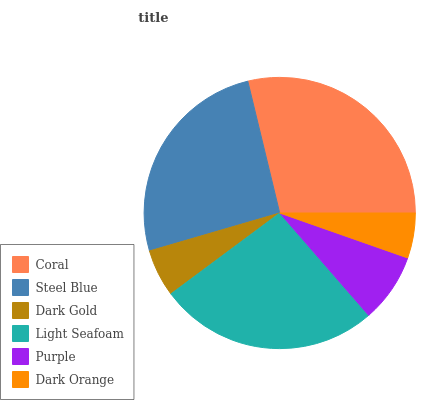Is Dark Orange the minimum?
Answer yes or no. Yes. Is Coral the maximum?
Answer yes or no. Yes. Is Steel Blue the minimum?
Answer yes or no. No. Is Steel Blue the maximum?
Answer yes or no. No. Is Coral greater than Steel Blue?
Answer yes or no. Yes. Is Steel Blue less than Coral?
Answer yes or no. Yes. Is Steel Blue greater than Coral?
Answer yes or no. No. Is Coral less than Steel Blue?
Answer yes or no. No. Is Steel Blue the high median?
Answer yes or no. Yes. Is Purple the low median?
Answer yes or no. Yes. Is Light Seafoam the high median?
Answer yes or no. No. Is Steel Blue the low median?
Answer yes or no. No. 